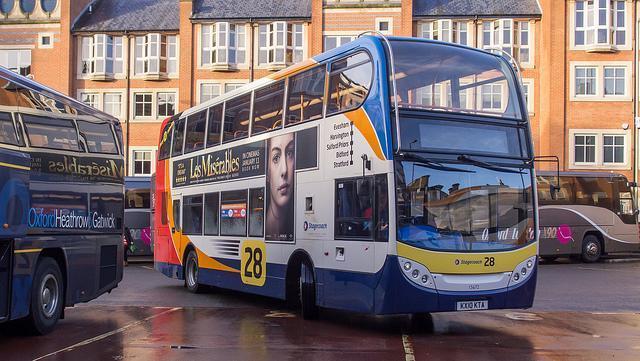How many buses are there?
Give a very brief answer. 3. 